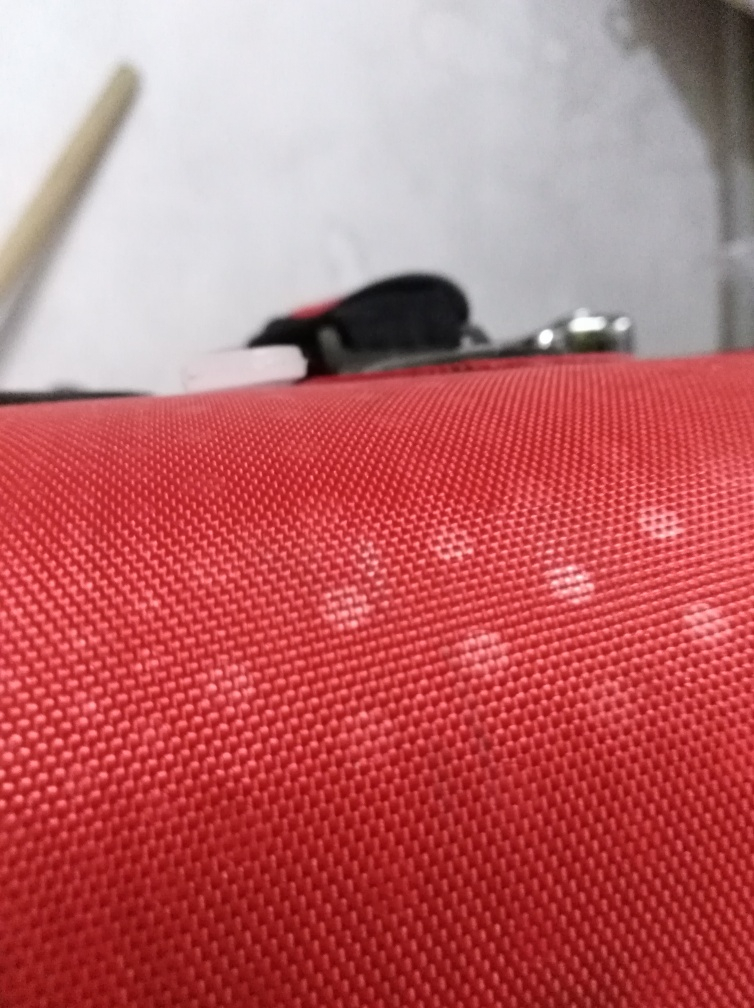Can you describe what's in the image? The image showcases a close-up of a textured surface with prominent woven or knitted pattern, likely a piece of fabric or material. The red-orange color predominates the view. In the blurred background, you can discern objects that might be part of a home or office setting, including what seems to be the edge of a black object which could be a bag or piece of furniture. The blurriness and perspective suggest the photo was taken at a short distance with a shallow depth of field. 